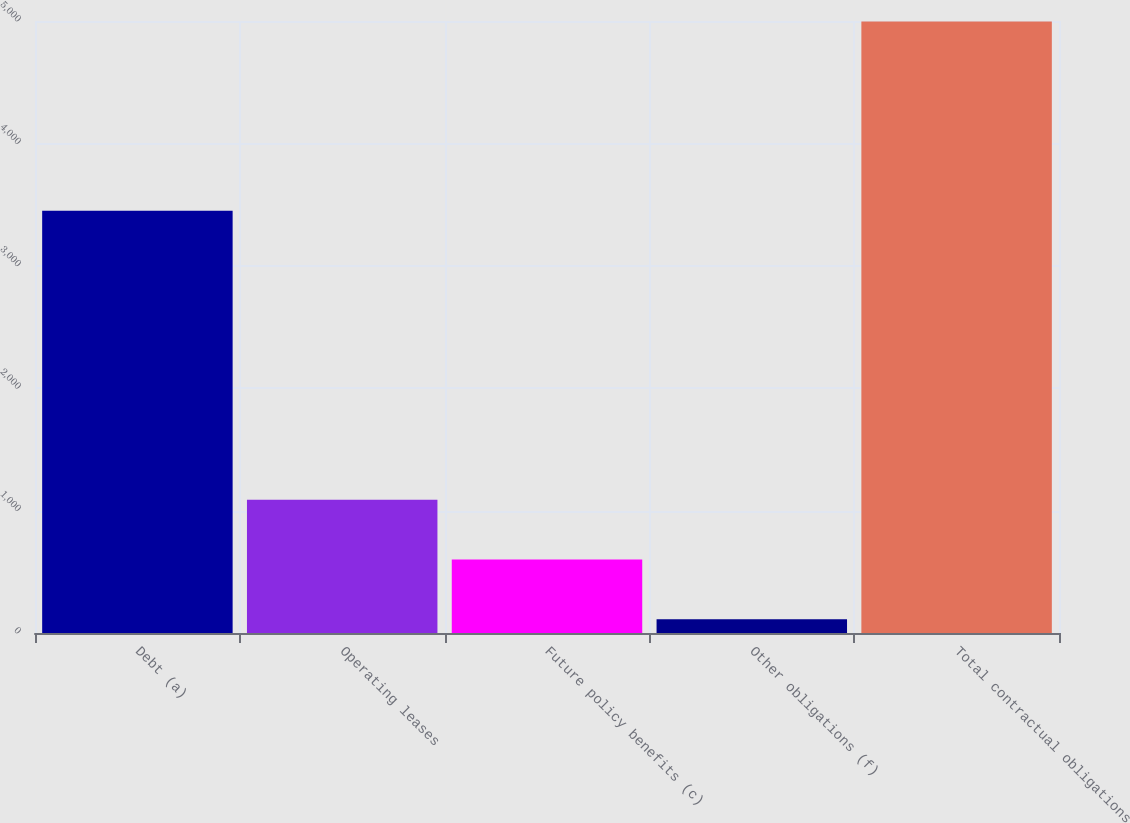<chart> <loc_0><loc_0><loc_500><loc_500><bar_chart><fcel>Debt (a)<fcel>Operating leases<fcel>Future policy benefits (c)<fcel>Other obligations (f)<fcel>Total contractual obligations<nl><fcel>3450<fcel>1089.6<fcel>601.3<fcel>113<fcel>4996<nl></chart> 